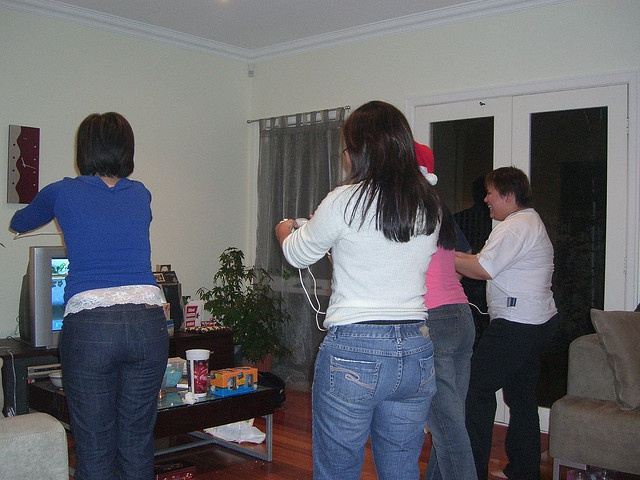Describe the objects in this image and their specific colors. I can see people in gray, lightgray, and black tones, people in gray, black, navy, and darkblue tones, people in gray, black, darkgray, and brown tones, couch in gray and black tones, and people in gray, black, and darkblue tones in this image. 